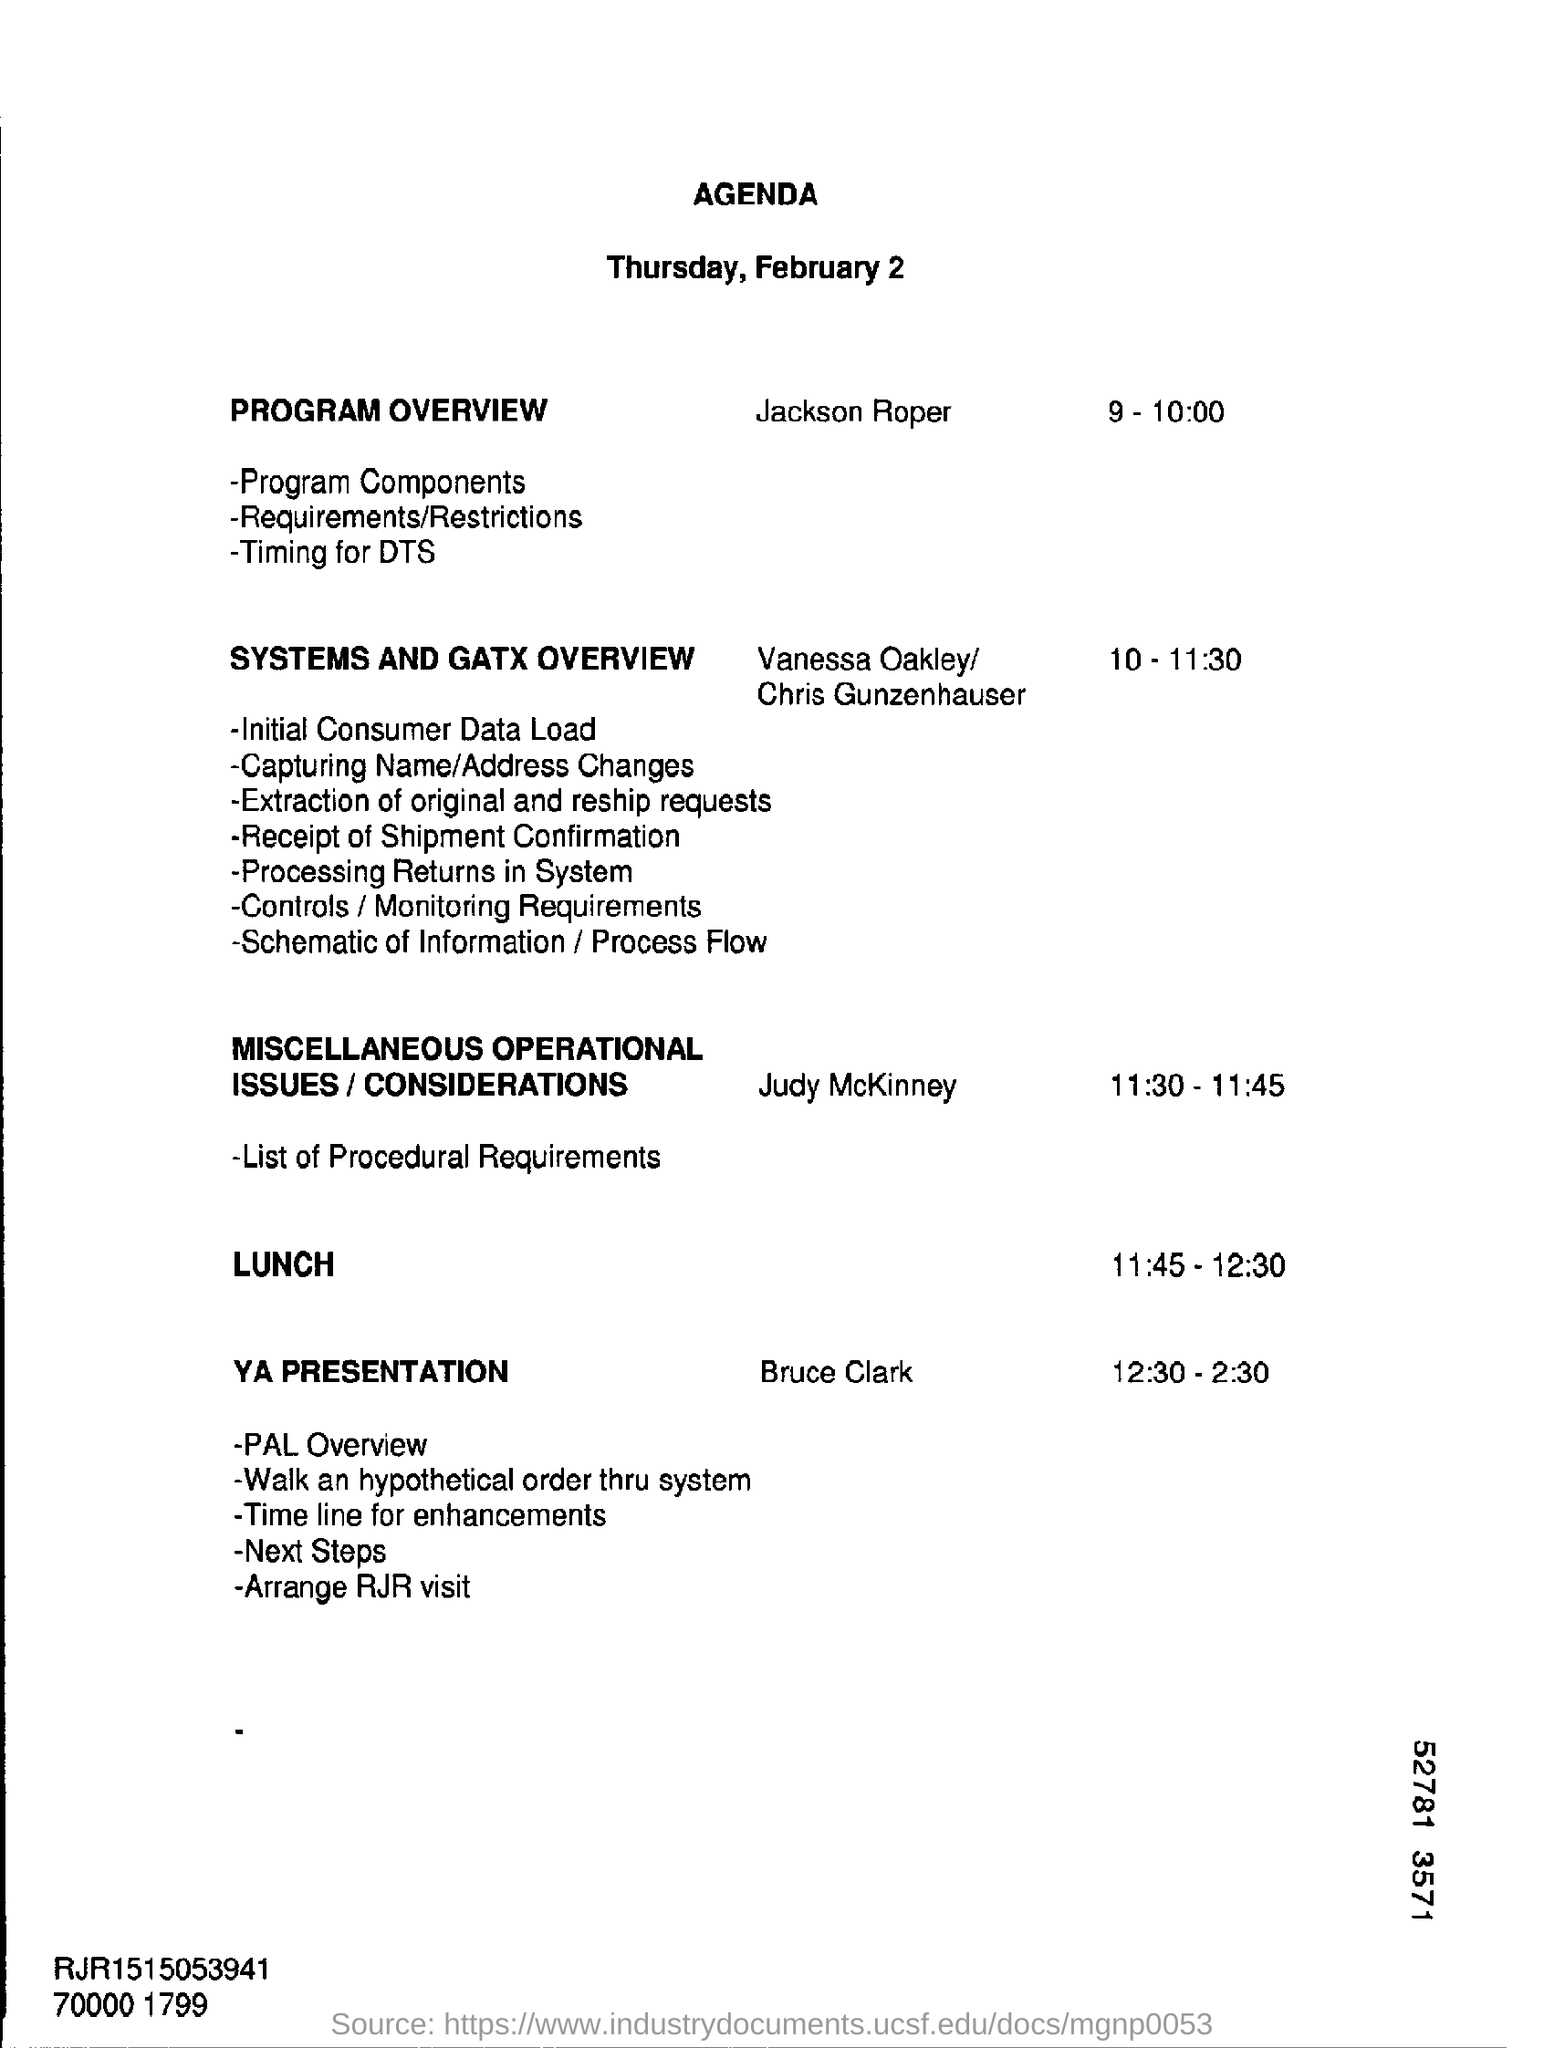Outline some significant characteristics in this image. The agenda was prepared for Thursday, February 2. It is Jackson Roper who is presenting the program overview. The lunch will be provided at 11:45-12:30. The presenter for the YA topic is Bruce Clark. At 10:00 - 11:30 on [date], the systems and GATX overview is scheduled. 